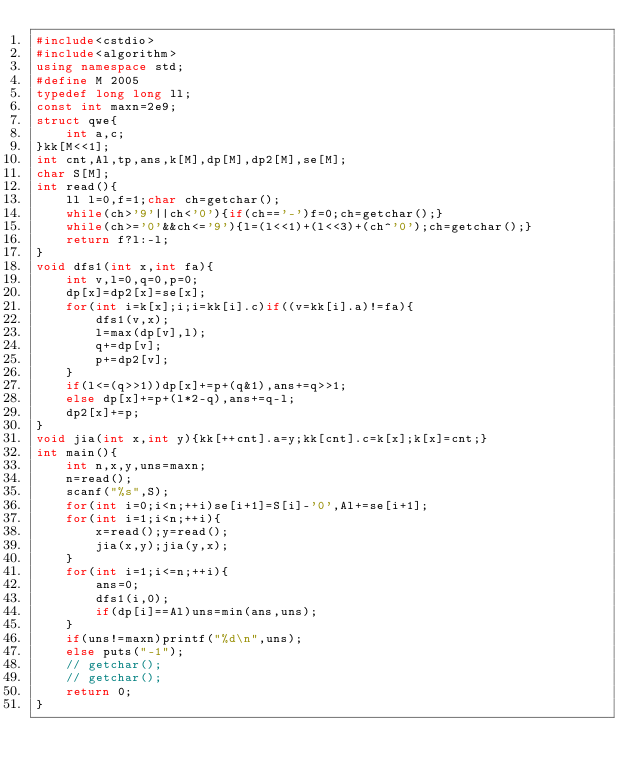Convert code to text. <code><loc_0><loc_0><loc_500><loc_500><_C++_>#include<cstdio>
#include<algorithm>
using namespace std;
#define M 2005
typedef long long ll;
const int maxn=2e9;
struct qwe{
    int a,c;
}kk[M<<1];
int cnt,Al,tp,ans,k[M],dp[M],dp2[M],se[M];
char S[M];
int read(){
    ll l=0,f=1;char ch=getchar();
    while(ch>'9'||ch<'0'){if(ch=='-')f=0;ch=getchar();}
    while(ch>='0'&&ch<='9'){l=(l<<1)+(l<<3)+(ch^'0');ch=getchar();}
    return f?l:-l;
}
void dfs1(int x,int fa){
    int v,l=0,q=0,p=0;
    dp[x]=dp2[x]=se[x];
    for(int i=k[x];i;i=kk[i].c)if((v=kk[i].a)!=fa){
        dfs1(v,x);
        l=max(dp[v],l);
        q+=dp[v];
        p+=dp2[v];
    }
    if(l<=(q>>1))dp[x]+=p+(q&1),ans+=q>>1;
    else dp[x]+=p+(l*2-q),ans+=q-l;
    dp2[x]+=p;
}
void jia(int x,int y){kk[++cnt].a=y;kk[cnt].c=k[x];k[x]=cnt;}
int main(){
    int n,x,y,uns=maxn;
    n=read();
    scanf("%s",S);
    for(int i=0;i<n;++i)se[i+1]=S[i]-'0',Al+=se[i+1];
    for(int i=1;i<n;++i){
        x=read();y=read();
        jia(x,y);jia(y,x);
    }
    for(int i=1;i<=n;++i){
        ans=0;
        dfs1(i,0);
        if(dp[i]==Al)uns=min(ans,uns);
    }
    if(uns!=maxn)printf("%d\n",uns);
    else puts("-1");
    // getchar();
    // getchar();
    return 0;
}</code> 